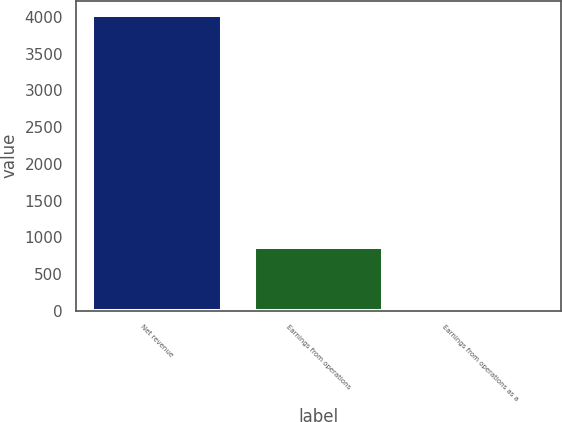<chart> <loc_0><loc_0><loc_500><loc_500><bar_chart><fcel>Net revenue<fcel>Earnings from operations<fcel>Earnings from operations as a<nl><fcel>4021<fcel>868<fcel>21.6<nl></chart> 